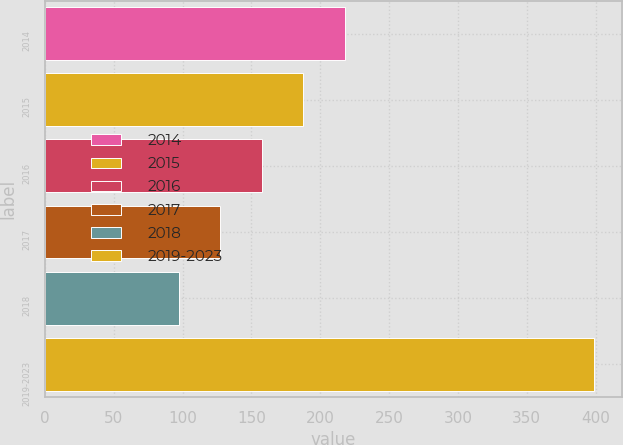<chart> <loc_0><loc_0><loc_500><loc_500><bar_chart><fcel>2014<fcel>2015<fcel>2016<fcel>2017<fcel>2018<fcel>2019-2023<nl><fcel>217.8<fcel>187.6<fcel>157.4<fcel>127.2<fcel>97<fcel>399<nl></chart> 